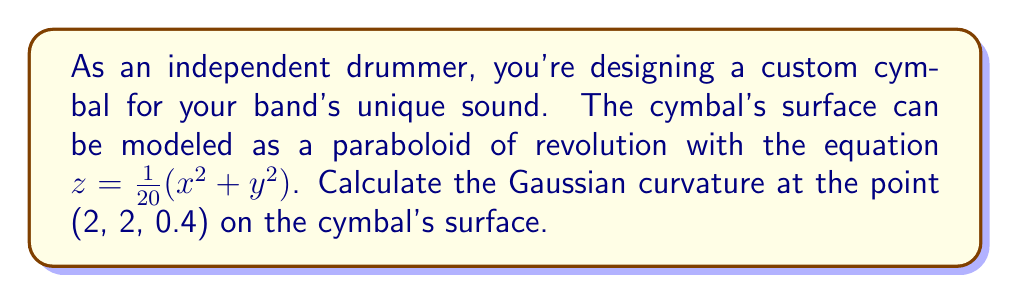Could you help me with this problem? To calculate the Gaussian curvature of the cymbal's surface, we'll follow these steps:

1) The surface is given by $z = f(x,y) = \frac{1}{20}(x^2 + y^2)$

2) We need to calculate the first and second partial derivatives:

   $f_x = \frac{x}{10}$, $f_y = \frac{y}{10}$
   $f_{xx} = \frac{1}{10}$, $f_{yy} = \frac{1}{10}$, $f_{xy} = 0$

3) The Gaussian curvature K is given by:

   $$K = \frac{f_{xx}f_{yy} - f_{xy}^2}{(1 + f_x^2 + f_y^2)^2}$$

4) At the point (2, 2, 0.4), we have:

   $f_x = \frac{2}{10} = 0.2$, $f_y = \frac{2}{10} = 0.2$
   $f_{xx} = \frac{1}{10}$, $f_{yy} = \frac{1}{10}$, $f_{xy} = 0$

5) Substituting these values into the formula:

   $$K = \frac{(\frac{1}{10})(\frac{1}{10}) - 0^2}{(1 + 0.2^2 + 0.2^2)^2}$$

6) Simplifying:

   $$K = \frac{\frac{1}{100}}{(1 + 0.08)^2} = \frac{\frac{1}{100}}{(1.08)^2} = \frac{\frac{1}{100}}{1.1664}$$

7) Calculate the final result:

   $$K \approx 0.0857$$
Answer: The Gaussian curvature at the point (2, 2, 0.4) on the cymbal's surface is approximately 0.0857. 